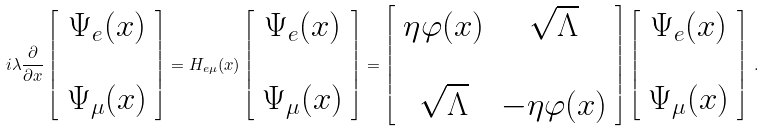<formula> <loc_0><loc_0><loc_500><loc_500>i \lambda \frac { \partial } { \partial x } \left [ \begin{array} { c c } \Psi _ { e } ( x ) \\ \\ \Psi _ { \mu } ( x ) \end{array} \right ] = H _ { e \mu } ( x ) \left [ \begin{array} { c c } \Psi _ { e } ( x ) \\ \\ \Psi _ { \mu } ( x ) \end{array} \right ] = \left [ \begin{array} { c c } \eta \varphi ( x ) & \sqrt { \Lambda } \\ \\ \sqrt { \Lambda } & - \eta \varphi ( x ) \end{array} \right ] \left [ \begin{array} { c c } \Psi _ { e } ( x ) \\ \\ \Psi _ { \mu } ( x ) \end{array} \right ] \, .</formula> 